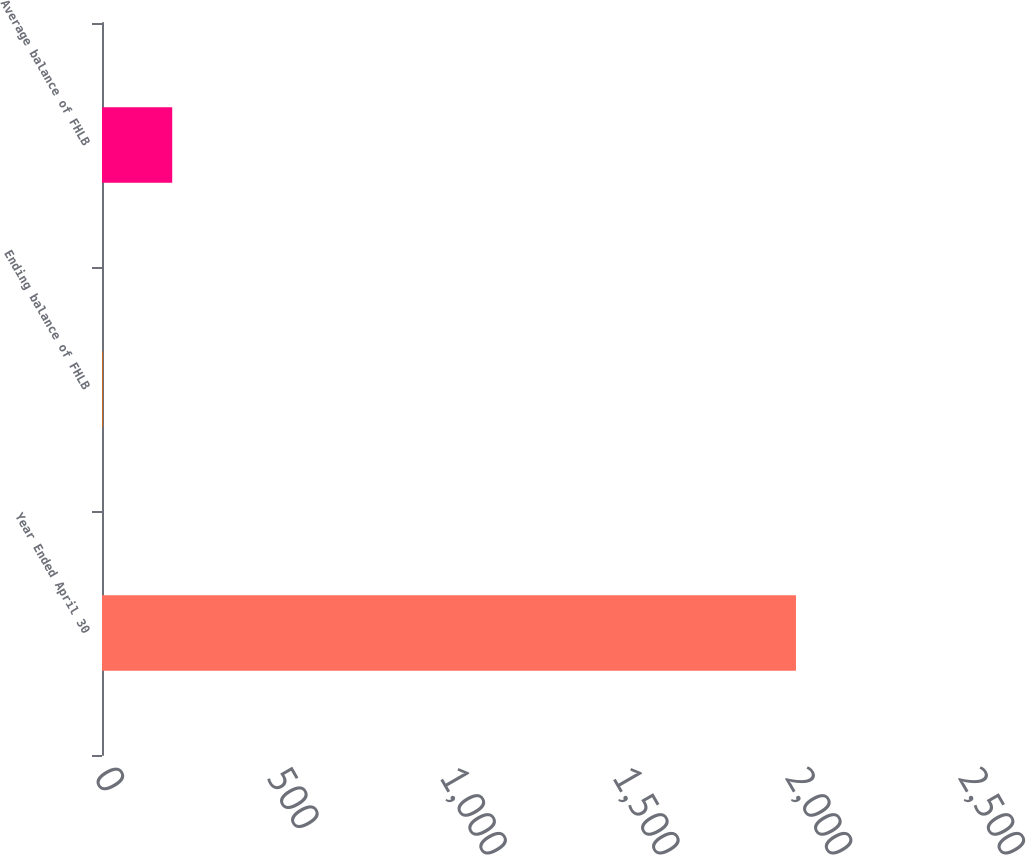Convert chart. <chart><loc_0><loc_0><loc_500><loc_500><bar_chart><fcel>Year Ended April 30<fcel>Ending balance of FHLB<fcel>Average balance of FHLB<nl><fcel>2008<fcel>2.64<fcel>203.18<nl></chart> 